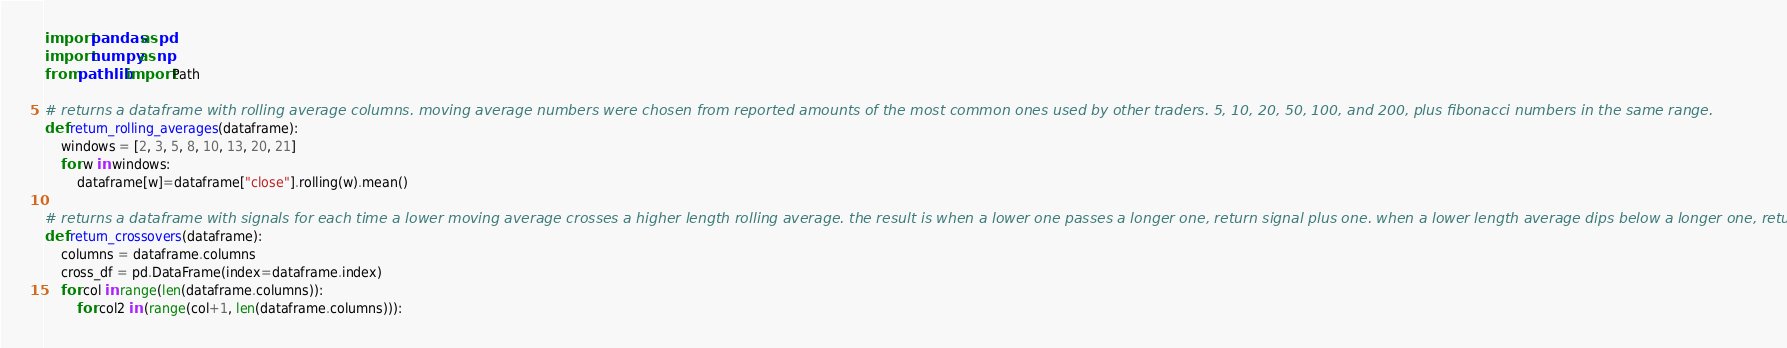Convert code to text. <code><loc_0><loc_0><loc_500><loc_500><_Python_>import pandas as pd
import numpy as np
from pathlib import Path

# returns a dataframe with rolling average columns. moving average numbers were chosen from reported amounts of the most common ones used by other traders. 5, 10, 20, 50, 100, and 200, plus fibonacci numbers in the same range.
def return_rolling_averages(dataframe):
    windows = [2, 3, 5, 8, 10, 13, 20, 21]
    for w in windows:
        dataframe[w]=dataframe["close"].rolling(w).mean()

# returns a dataframe with signals for each time a lower moving average crosses a higher length rolling average. the result is when a lower one passes a longer one, return signal plus one. when a lower length average dips below a longer one, return signal negative one.
def return_crossovers(dataframe):
    columns = dataframe.columns
    cross_df = pd.DataFrame(index=dataframe.index)
    for col in range(len(dataframe.columns)):
        for col2 in (range(col+1, len(dataframe.columns))):</code> 